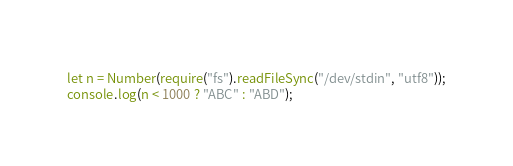Convert code to text. <code><loc_0><loc_0><loc_500><loc_500><_JavaScript_>let n = Number(require("fs").readFileSync("/dev/stdin", "utf8"));
console.log(n < 1000 ? "ABC" : "ABD");</code> 